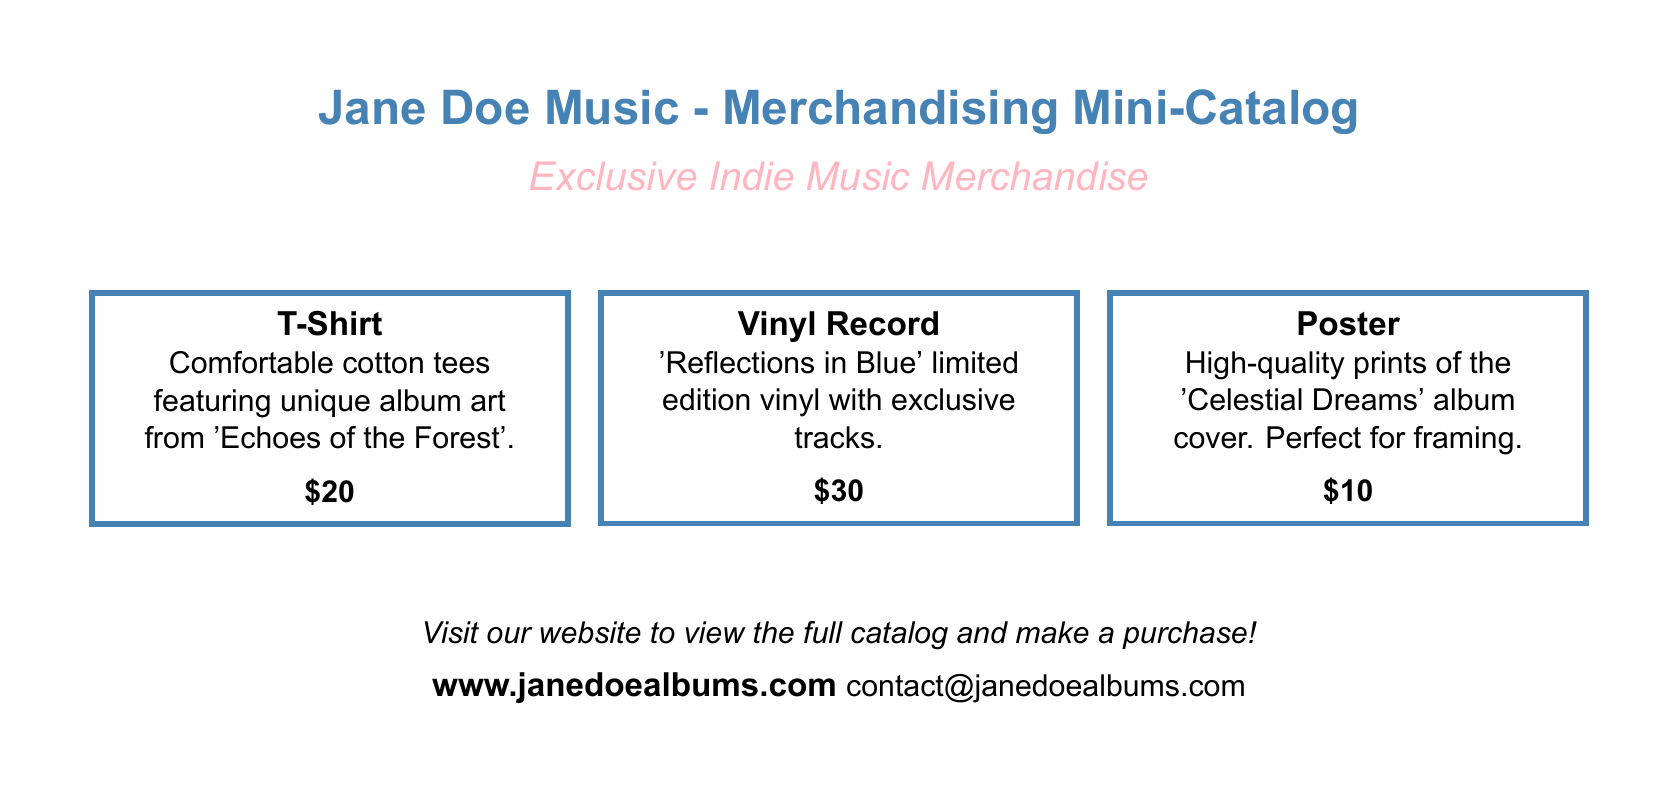what is the price of the T-shirt? The price of the T-shirt is listed in the document under the T-shirt description.
Answer: $20 what is the title of the limited edition vinyl? The document specifies the title of the limited edition vinyl in the vinyl record section.
Answer: Reflections in Blue how much does the poster cost? The cost of the poster is mentioned in the associated description within the document.
Answer: $10 what is the website for purchasing merchandise? The website is provided in the document for viewing the full catalog and making a purchase.
Answer: www.janedoealbums.com how many types of merchandise are listed in the document? The document lists types of merchandise in separate framed sections, which can be counted.
Answer: 3 which album art is featured on the T-shirt? The T-shirt description cites the album whose art is showcased on it.
Answer: Echoes of the Forest what color category is used for the title of the document? The color used for the document's title is specified in the preamble of the document.
Answer: indieblue what type of print is the poster described as? The document describes the poster in terms of its quality and use mentioned in the description.
Answer: High-quality prints 